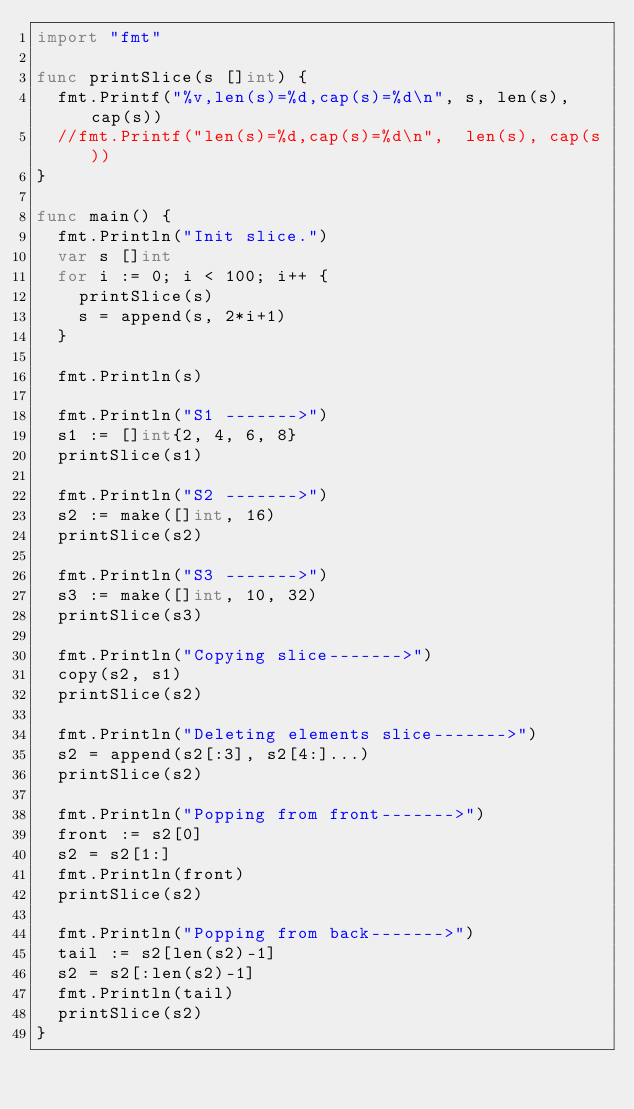Convert code to text. <code><loc_0><loc_0><loc_500><loc_500><_Go_>import "fmt"

func printSlice(s []int) {
	fmt.Printf("%v,len(s)=%d,cap(s)=%d\n", s, len(s), cap(s))
	//fmt.Printf("len(s)=%d,cap(s)=%d\n",  len(s), cap(s))
}

func main() {
	fmt.Println("Init slice.")
	var s []int
	for i := 0; i < 100; i++ {
		printSlice(s)
		s = append(s, 2*i+1)
	}

	fmt.Println(s)

	fmt.Println("S1 ------->")
	s1 := []int{2, 4, 6, 8}
	printSlice(s1)

	fmt.Println("S2 ------->")
	s2 := make([]int, 16)
	printSlice(s2)

	fmt.Println("S3 ------->")
	s3 := make([]int, 10, 32)
	printSlice(s3)

	fmt.Println("Copying slice------->")
	copy(s2, s1)
	printSlice(s2)

	fmt.Println("Deleting elements slice------->")
	s2 = append(s2[:3], s2[4:]...)
	printSlice(s2)

	fmt.Println("Popping from front------->")
	front := s2[0]
	s2 = s2[1:]
	fmt.Println(front)
	printSlice(s2)

	fmt.Println("Popping from back------->")
	tail := s2[len(s2)-1]
	s2 = s2[:len(s2)-1]
	fmt.Println(tail)
	printSlice(s2)
}
</code> 